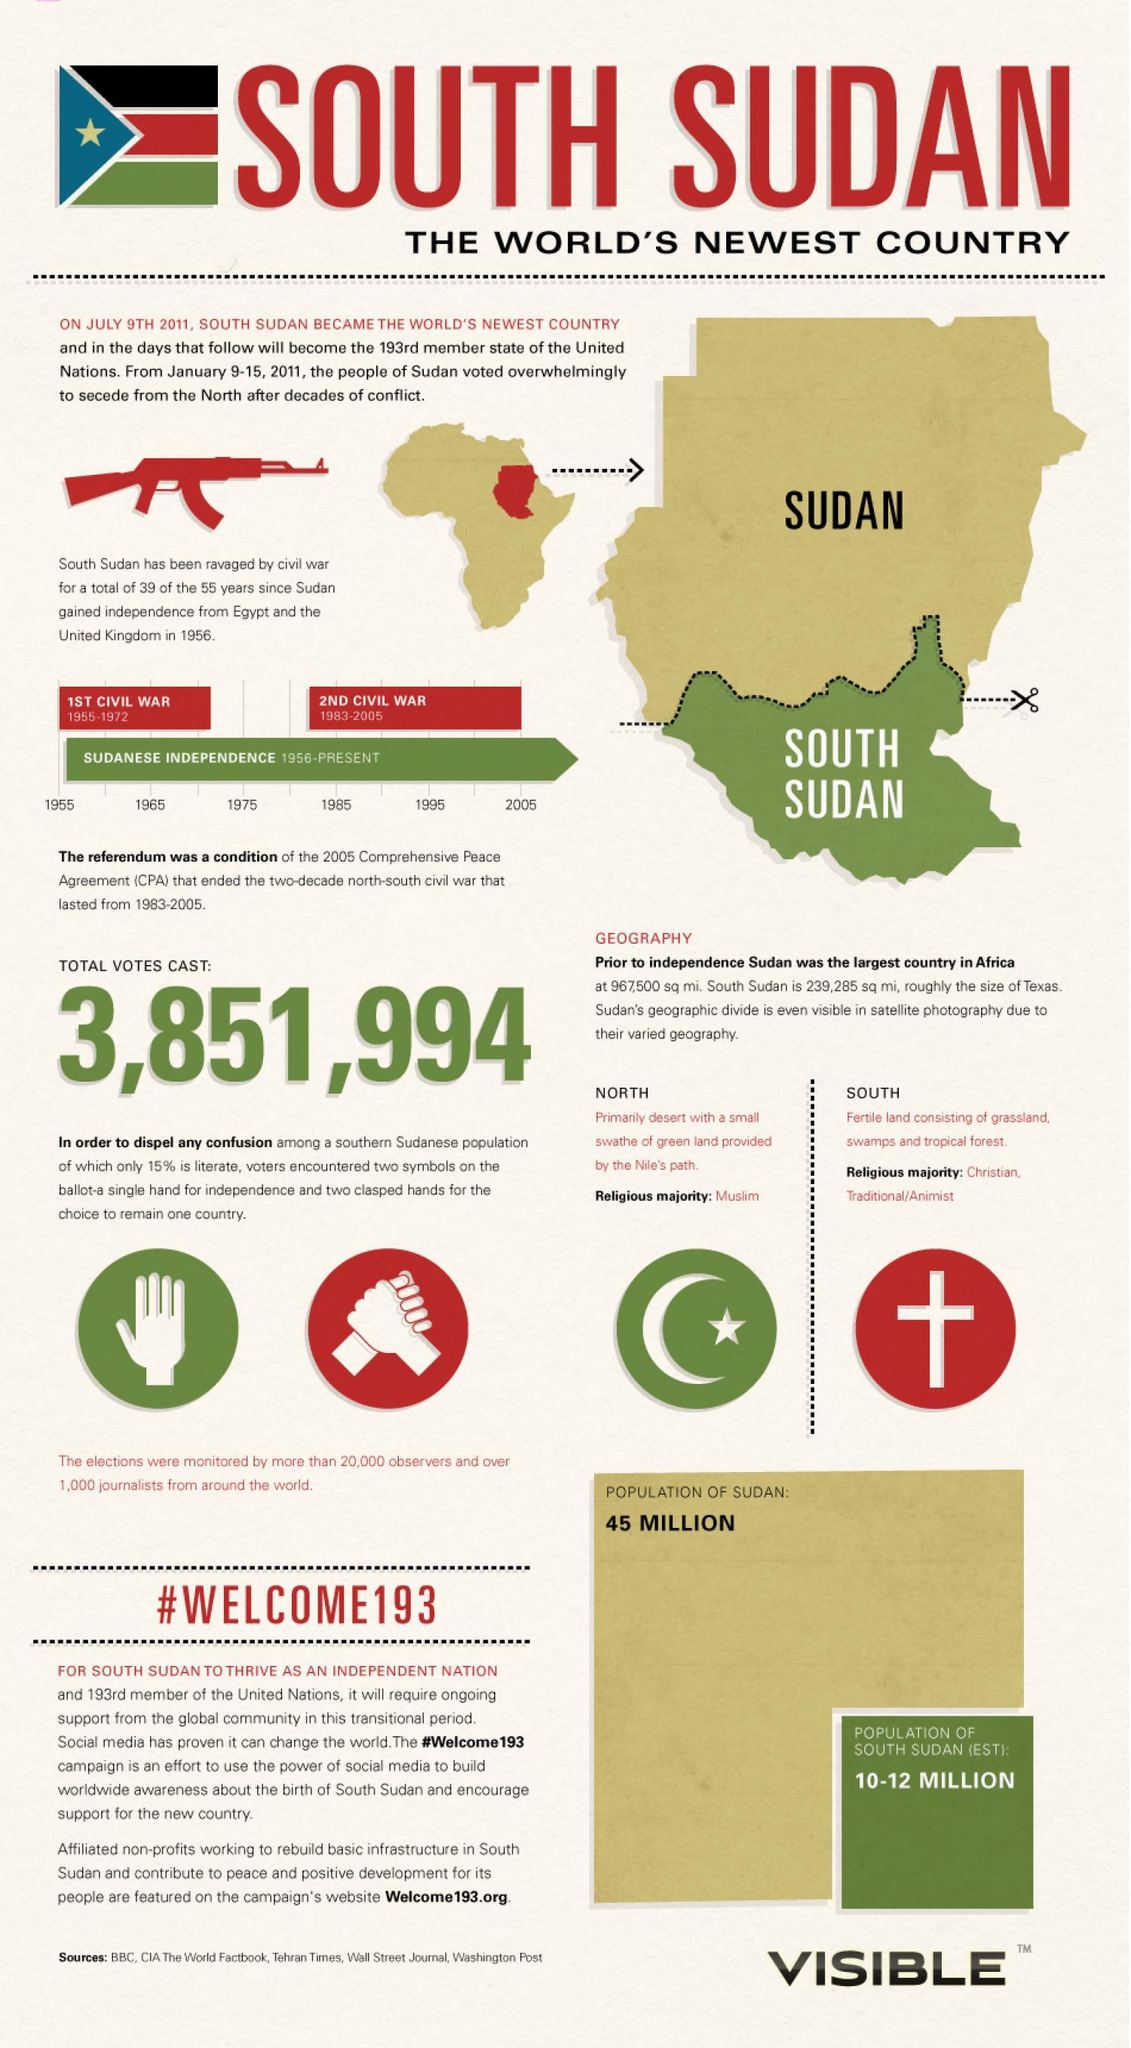When did the Second Sudanese Civil War started?
Answer the question with a short phrase. 1983 When did Sudan gain independence from Britain? 1956 How many civil wars were there in Sudan? 2 What is the religious majority in North Sudan? Muslim 